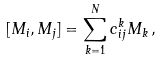Convert formula to latex. <formula><loc_0><loc_0><loc_500><loc_500>[ M _ { i } , M _ { j } ] = \sum _ { k = 1 } ^ { N } c _ { i j } ^ { k } M _ { k } \, ,</formula> 